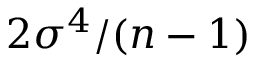Convert formula to latex. <formula><loc_0><loc_0><loc_500><loc_500>2 \sigma ^ { 4 } / ( n - 1 )</formula> 